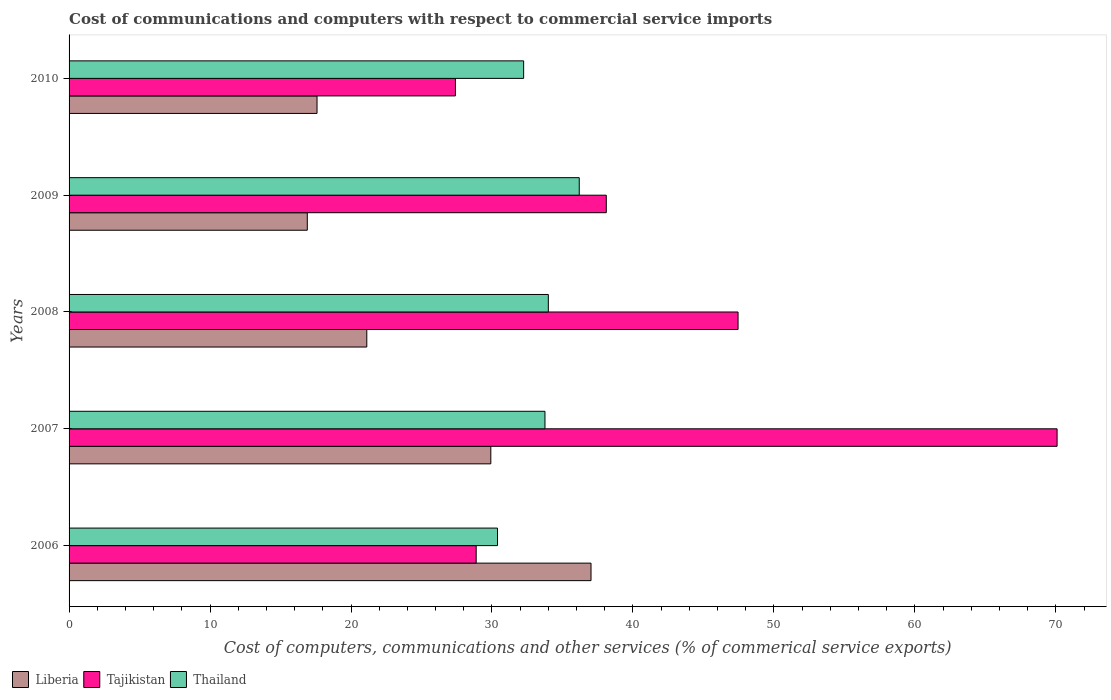Are the number of bars per tick equal to the number of legend labels?
Offer a very short reply. Yes. How many bars are there on the 1st tick from the top?
Your answer should be very brief. 3. How many bars are there on the 4th tick from the bottom?
Ensure brevity in your answer.  3. What is the label of the 5th group of bars from the top?
Your response must be concise. 2006. What is the cost of communications and computers in Thailand in 2010?
Your answer should be compact. 32.25. Across all years, what is the maximum cost of communications and computers in Tajikistan?
Provide a short and direct response. 70.09. Across all years, what is the minimum cost of communications and computers in Thailand?
Offer a very short reply. 30.39. In which year was the cost of communications and computers in Tajikistan minimum?
Ensure brevity in your answer.  2010. What is the total cost of communications and computers in Thailand in the graph?
Your answer should be very brief. 166.59. What is the difference between the cost of communications and computers in Tajikistan in 2007 and that in 2009?
Keep it short and to the point. 31.98. What is the difference between the cost of communications and computers in Thailand in 2010 and the cost of communications and computers in Liberia in 2006?
Make the answer very short. -4.78. What is the average cost of communications and computers in Tajikistan per year?
Offer a terse response. 42.39. In the year 2006, what is the difference between the cost of communications and computers in Tajikistan and cost of communications and computers in Thailand?
Your answer should be very brief. -1.51. What is the ratio of the cost of communications and computers in Thailand in 2008 to that in 2009?
Keep it short and to the point. 0.94. Is the difference between the cost of communications and computers in Tajikistan in 2007 and 2009 greater than the difference between the cost of communications and computers in Thailand in 2007 and 2009?
Keep it short and to the point. Yes. What is the difference between the highest and the second highest cost of communications and computers in Liberia?
Make the answer very short. 7.11. What is the difference between the highest and the lowest cost of communications and computers in Thailand?
Provide a succinct answer. 5.8. In how many years, is the cost of communications and computers in Liberia greater than the average cost of communications and computers in Liberia taken over all years?
Offer a terse response. 2. Is the sum of the cost of communications and computers in Thailand in 2006 and 2010 greater than the maximum cost of communications and computers in Liberia across all years?
Your answer should be compact. Yes. What does the 1st bar from the top in 2007 represents?
Offer a terse response. Thailand. What does the 1st bar from the bottom in 2007 represents?
Ensure brevity in your answer.  Liberia. Is it the case that in every year, the sum of the cost of communications and computers in Thailand and cost of communications and computers in Tajikistan is greater than the cost of communications and computers in Liberia?
Keep it short and to the point. Yes. Are all the bars in the graph horizontal?
Provide a succinct answer. Yes. How many years are there in the graph?
Your answer should be very brief. 5. Where does the legend appear in the graph?
Your answer should be compact. Bottom left. How many legend labels are there?
Provide a succinct answer. 3. How are the legend labels stacked?
Offer a very short reply. Horizontal. What is the title of the graph?
Give a very brief answer. Cost of communications and computers with respect to commercial service imports. Does "Suriname" appear as one of the legend labels in the graph?
Keep it short and to the point. No. What is the label or title of the X-axis?
Your answer should be compact. Cost of computers, communications and other services (% of commerical service exports). What is the label or title of the Y-axis?
Keep it short and to the point. Years. What is the Cost of computers, communications and other services (% of commerical service exports) of Liberia in 2006?
Offer a very short reply. 37.03. What is the Cost of computers, communications and other services (% of commerical service exports) of Tajikistan in 2006?
Your answer should be compact. 28.88. What is the Cost of computers, communications and other services (% of commerical service exports) in Thailand in 2006?
Your answer should be compact. 30.39. What is the Cost of computers, communications and other services (% of commerical service exports) in Liberia in 2007?
Give a very brief answer. 29.92. What is the Cost of computers, communications and other services (% of commerical service exports) in Tajikistan in 2007?
Your response must be concise. 70.09. What is the Cost of computers, communications and other services (% of commerical service exports) in Thailand in 2007?
Your response must be concise. 33.76. What is the Cost of computers, communications and other services (% of commerical service exports) in Liberia in 2008?
Give a very brief answer. 21.12. What is the Cost of computers, communications and other services (% of commerical service exports) in Tajikistan in 2008?
Give a very brief answer. 47.46. What is the Cost of computers, communications and other services (% of commerical service exports) of Thailand in 2008?
Make the answer very short. 34. What is the Cost of computers, communications and other services (% of commerical service exports) of Liberia in 2009?
Provide a short and direct response. 16.9. What is the Cost of computers, communications and other services (% of commerical service exports) in Tajikistan in 2009?
Keep it short and to the point. 38.11. What is the Cost of computers, communications and other services (% of commerical service exports) of Thailand in 2009?
Offer a terse response. 36.19. What is the Cost of computers, communications and other services (% of commerical service exports) in Liberia in 2010?
Offer a terse response. 17.59. What is the Cost of computers, communications and other services (% of commerical service exports) of Tajikistan in 2010?
Give a very brief answer. 27.41. What is the Cost of computers, communications and other services (% of commerical service exports) in Thailand in 2010?
Give a very brief answer. 32.25. Across all years, what is the maximum Cost of computers, communications and other services (% of commerical service exports) of Liberia?
Offer a very short reply. 37.03. Across all years, what is the maximum Cost of computers, communications and other services (% of commerical service exports) of Tajikistan?
Keep it short and to the point. 70.09. Across all years, what is the maximum Cost of computers, communications and other services (% of commerical service exports) of Thailand?
Offer a terse response. 36.19. Across all years, what is the minimum Cost of computers, communications and other services (% of commerical service exports) of Liberia?
Give a very brief answer. 16.9. Across all years, what is the minimum Cost of computers, communications and other services (% of commerical service exports) in Tajikistan?
Keep it short and to the point. 27.41. Across all years, what is the minimum Cost of computers, communications and other services (% of commerical service exports) in Thailand?
Your answer should be very brief. 30.39. What is the total Cost of computers, communications and other services (% of commerical service exports) of Liberia in the graph?
Give a very brief answer. 122.55. What is the total Cost of computers, communications and other services (% of commerical service exports) of Tajikistan in the graph?
Keep it short and to the point. 211.94. What is the total Cost of computers, communications and other services (% of commerical service exports) of Thailand in the graph?
Provide a short and direct response. 166.59. What is the difference between the Cost of computers, communications and other services (% of commerical service exports) of Liberia in 2006 and that in 2007?
Ensure brevity in your answer.  7.11. What is the difference between the Cost of computers, communications and other services (% of commerical service exports) of Tajikistan in 2006 and that in 2007?
Offer a very short reply. -41.21. What is the difference between the Cost of computers, communications and other services (% of commerical service exports) of Thailand in 2006 and that in 2007?
Provide a short and direct response. -3.37. What is the difference between the Cost of computers, communications and other services (% of commerical service exports) of Liberia in 2006 and that in 2008?
Your answer should be very brief. 15.91. What is the difference between the Cost of computers, communications and other services (% of commerical service exports) in Tajikistan in 2006 and that in 2008?
Offer a terse response. -18.58. What is the difference between the Cost of computers, communications and other services (% of commerical service exports) in Thailand in 2006 and that in 2008?
Your response must be concise. -3.6. What is the difference between the Cost of computers, communications and other services (% of commerical service exports) of Liberia in 2006 and that in 2009?
Ensure brevity in your answer.  20.13. What is the difference between the Cost of computers, communications and other services (% of commerical service exports) of Tajikistan in 2006 and that in 2009?
Your response must be concise. -9.23. What is the difference between the Cost of computers, communications and other services (% of commerical service exports) in Thailand in 2006 and that in 2009?
Offer a very short reply. -5.8. What is the difference between the Cost of computers, communications and other services (% of commerical service exports) of Liberia in 2006 and that in 2010?
Keep it short and to the point. 19.44. What is the difference between the Cost of computers, communications and other services (% of commerical service exports) in Tajikistan in 2006 and that in 2010?
Give a very brief answer. 1.47. What is the difference between the Cost of computers, communications and other services (% of commerical service exports) in Thailand in 2006 and that in 2010?
Your response must be concise. -1.85. What is the difference between the Cost of computers, communications and other services (% of commerical service exports) in Liberia in 2007 and that in 2008?
Offer a very short reply. 8.8. What is the difference between the Cost of computers, communications and other services (% of commerical service exports) of Tajikistan in 2007 and that in 2008?
Provide a succinct answer. 22.63. What is the difference between the Cost of computers, communications and other services (% of commerical service exports) of Thailand in 2007 and that in 2008?
Provide a short and direct response. -0.24. What is the difference between the Cost of computers, communications and other services (% of commerical service exports) of Liberia in 2007 and that in 2009?
Offer a very short reply. 13.02. What is the difference between the Cost of computers, communications and other services (% of commerical service exports) of Tajikistan in 2007 and that in 2009?
Offer a terse response. 31.98. What is the difference between the Cost of computers, communications and other services (% of commerical service exports) of Thailand in 2007 and that in 2009?
Offer a terse response. -2.43. What is the difference between the Cost of computers, communications and other services (% of commerical service exports) of Liberia in 2007 and that in 2010?
Give a very brief answer. 12.33. What is the difference between the Cost of computers, communications and other services (% of commerical service exports) of Tajikistan in 2007 and that in 2010?
Your response must be concise. 42.68. What is the difference between the Cost of computers, communications and other services (% of commerical service exports) of Thailand in 2007 and that in 2010?
Provide a short and direct response. 1.51. What is the difference between the Cost of computers, communications and other services (% of commerical service exports) in Liberia in 2008 and that in 2009?
Offer a very short reply. 4.22. What is the difference between the Cost of computers, communications and other services (% of commerical service exports) of Tajikistan in 2008 and that in 2009?
Provide a succinct answer. 9.35. What is the difference between the Cost of computers, communications and other services (% of commerical service exports) of Thailand in 2008 and that in 2009?
Offer a very short reply. -2.19. What is the difference between the Cost of computers, communications and other services (% of commerical service exports) in Liberia in 2008 and that in 2010?
Give a very brief answer. 3.53. What is the difference between the Cost of computers, communications and other services (% of commerical service exports) of Tajikistan in 2008 and that in 2010?
Your answer should be very brief. 20.05. What is the difference between the Cost of computers, communications and other services (% of commerical service exports) in Thailand in 2008 and that in 2010?
Your answer should be compact. 1.75. What is the difference between the Cost of computers, communications and other services (% of commerical service exports) of Liberia in 2009 and that in 2010?
Give a very brief answer. -0.69. What is the difference between the Cost of computers, communications and other services (% of commerical service exports) of Tajikistan in 2009 and that in 2010?
Give a very brief answer. 10.7. What is the difference between the Cost of computers, communications and other services (% of commerical service exports) in Thailand in 2009 and that in 2010?
Offer a very short reply. 3.94. What is the difference between the Cost of computers, communications and other services (% of commerical service exports) in Liberia in 2006 and the Cost of computers, communications and other services (% of commerical service exports) in Tajikistan in 2007?
Provide a succinct answer. -33.06. What is the difference between the Cost of computers, communications and other services (% of commerical service exports) of Liberia in 2006 and the Cost of computers, communications and other services (% of commerical service exports) of Thailand in 2007?
Provide a short and direct response. 3.27. What is the difference between the Cost of computers, communications and other services (% of commerical service exports) of Tajikistan in 2006 and the Cost of computers, communications and other services (% of commerical service exports) of Thailand in 2007?
Your answer should be very brief. -4.88. What is the difference between the Cost of computers, communications and other services (% of commerical service exports) of Liberia in 2006 and the Cost of computers, communications and other services (% of commerical service exports) of Tajikistan in 2008?
Your answer should be very brief. -10.43. What is the difference between the Cost of computers, communications and other services (% of commerical service exports) in Liberia in 2006 and the Cost of computers, communications and other services (% of commerical service exports) in Thailand in 2008?
Your answer should be compact. 3.03. What is the difference between the Cost of computers, communications and other services (% of commerical service exports) in Tajikistan in 2006 and the Cost of computers, communications and other services (% of commerical service exports) in Thailand in 2008?
Your answer should be very brief. -5.12. What is the difference between the Cost of computers, communications and other services (% of commerical service exports) in Liberia in 2006 and the Cost of computers, communications and other services (% of commerical service exports) in Tajikistan in 2009?
Your response must be concise. -1.08. What is the difference between the Cost of computers, communications and other services (% of commerical service exports) of Liberia in 2006 and the Cost of computers, communications and other services (% of commerical service exports) of Thailand in 2009?
Your answer should be compact. 0.83. What is the difference between the Cost of computers, communications and other services (% of commerical service exports) in Tajikistan in 2006 and the Cost of computers, communications and other services (% of commerical service exports) in Thailand in 2009?
Provide a succinct answer. -7.31. What is the difference between the Cost of computers, communications and other services (% of commerical service exports) of Liberia in 2006 and the Cost of computers, communications and other services (% of commerical service exports) of Tajikistan in 2010?
Offer a terse response. 9.62. What is the difference between the Cost of computers, communications and other services (% of commerical service exports) in Liberia in 2006 and the Cost of computers, communications and other services (% of commerical service exports) in Thailand in 2010?
Ensure brevity in your answer.  4.78. What is the difference between the Cost of computers, communications and other services (% of commerical service exports) of Tajikistan in 2006 and the Cost of computers, communications and other services (% of commerical service exports) of Thailand in 2010?
Make the answer very short. -3.37. What is the difference between the Cost of computers, communications and other services (% of commerical service exports) in Liberia in 2007 and the Cost of computers, communications and other services (% of commerical service exports) in Tajikistan in 2008?
Your response must be concise. -17.54. What is the difference between the Cost of computers, communications and other services (% of commerical service exports) of Liberia in 2007 and the Cost of computers, communications and other services (% of commerical service exports) of Thailand in 2008?
Ensure brevity in your answer.  -4.08. What is the difference between the Cost of computers, communications and other services (% of commerical service exports) of Tajikistan in 2007 and the Cost of computers, communications and other services (% of commerical service exports) of Thailand in 2008?
Offer a terse response. 36.09. What is the difference between the Cost of computers, communications and other services (% of commerical service exports) of Liberia in 2007 and the Cost of computers, communications and other services (% of commerical service exports) of Tajikistan in 2009?
Offer a very short reply. -8.19. What is the difference between the Cost of computers, communications and other services (% of commerical service exports) of Liberia in 2007 and the Cost of computers, communications and other services (% of commerical service exports) of Thailand in 2009?
Keep it short and to the point. -6.27. What is the difference between the Cost of computers, communications and other services (% of commerical service exports) of Tajikistan in 2007 and the Cost of computers, communications and other services (% of commerical service exports) of Thailand in 2009?
Ensure brevity in your answer.  33.9. What is the difference between the Cost of computers, communications and other services (% of commerical service exports) in Liberia in 2007 and the Cost of computers, communications and other services (% of commerical service exports) in Tajikistan in 2010?
Give a very brief answer. 2.51. What is the difference between the Cost of computers, communications and other services (% of commerical service exports) of Liberia in 2007 and the Cost of computers, communications and other services (% of commerical service exports) of Thailand in 2010?
Your response must be concise. -2.33. What is the difference between the Cost of computers, communications and other services (% of commerical service exports) of Tajikistan in 2007 and the Cost of computers, communications and other services (% of commerical service exports) of Thailand in 2010?
Offer a very short reply. 37.84. What is the difference between the Cost of computers, communications and other services (% of commerical service exports) of Liberia in 2008 and the Cost of computers, communications and other services (% of commerical service exports) of Tajikistan in 2009?
Offer a very short reply. -16.99. What is the difference between the Cost of computers, communications and other services (% of commerical service exports) in Liberia in 2008 and the Cost of computers, communications and other services (% of commerical service exports) in Thailand in 2009?
Offer a very short reply. -15.07. What is the difference between the Cost of computers, communications and other services (% of commerical service exports) of Tajikistan in 2008 and the Cost of computers, communications and other services (% of commerical service exports) of Thailand in 2009?
Give a very brief answer. 11.27. What is the difference between the Cost of computers, communications and other services (% of commerical service exports) of Liberia in 2008 and the Cost of computers, communications and other services (% of commerical service exports) of Tajikistan in 2010?
Your answer should be very brief. -6.29. What is the difference between the Cost of computers, communications and other services (% of commerical service exports) of Liberia in 2008 and the Cost of computers, communications and other services (% of commerical service exports) of Thailand in 2010?
Your response must be concise. -11.13. What is the difference between the Cost of computers, communications and other services (% of commerical service exports) of Tajikistan in 2008 and the Cost of computers, communications and other services (% of commerical service exports) of Thailand in 2010?
Your response must be concise. 15.21. What is the difference between the Cost of computers, communications and other services (% of commerical service exports) of Liberia in 2009 and the Cost of computers, communications and other services (% of commerical service exports) of Tajikistan in 2010?
Provide a succinct answer. -10.51. What is the difference between the Cost of computers, communications and other services (% of commerical service exports) in Liberia in 2009 and the Cost of computers, communications and other services (% of commerical service exports) in Thailand in 2010?
Ensure brevity in your answer.  -15.35. What is the difference between the Cost of computers, communications and other services (% of commerical service exports) in Tajikistan in 2009 and the Cost of computers, communications and other services (% of commerical service exports) in Thailand in 2010?
Ensure brevity in your answer.  5.86. What is the average Cost of computers, communications and other services (% of commerical service exports) of Liberia per year?
Make the answer very short. 24.51. What is the average Cost of computers, communications and other services (% of commerical service exports) of Tajikistan per year?
Provide a succinct answer. 42.39. What is the average Cost of computers, communications and other services (% of commerical service exports) in Thailand per year?
Keep it short and to the point. 33.32. In the year 2006, what is the difference between the Cost of computers, communications and other services (% of commerical service exports) in Liberia and Cost of computers, communications and other services (% of commerical service exports) in Tajikistan?
Your answer should be very brief. 8.15. In the year 2006, what is the difference between the Cost of computers, communications and other services (% of commerical service exports) in Liberia and Cost of computers, communications and other services (% of commerical service exports) in Thailand?
Keep it short and to the point. 6.63. In the year 2006, what is the difference between the Cost of computers, communications and other services (% of commerical service exports) of Tajikistan and Cost of computers, communications and other services (% of commerical service exports) of Thailand?
Keep it short and to the point. -1.51. In the year 2007, what is the difference between the Cost of computers, communications and other services (% of commerical service exports) of Liberia and Cost of computers, communications and other services (% of commerical service exports) of Tajikistan?
Your answer should be very brief. -40.17. In the year 2007, what is the difference between the Cost of computers, communications and other services (% of commerical service exports) of Liberia and Cost of computers, communications and other services (% of commerical service exports) of Thailand?
Your answer should be very brief. -3.84. In the year 2007, what is the difference between the Cost of computers, communications and other services (% of commerical service exports) of Tajikistan and Cost of computers, communications and other services (% of commerical service exports) of Thailand?
Ensure brevity in your answer.  36.33. In the year 2008, what is the difference between the Cost of computers, communications and other services (% of commerical service exports) in Liberia and Cost of computers, communications and other services (% of commerical service exports) in Tajikistan?
Give a very brief answer. -26.34. In the year 2008, what is the difference between the Cost of computers, communications and other services (% of commerical service exports) in Liberia and Cost of computers, communications and other services (% of commerical service exports) in Thailand?
Offer a terse response. -12.88. In the year 2008, what is the difference between the Cost of computers, communications and other services (% of commerical service exports) of Tajikistan and Cost of computers, communications and other services (% of commerical service exports) of Thailand?
Give a very brief answer. 13.46. In the year 2009, what is the difference between the Cost of computers, communications and other services (% of commerical service exports) in Liberia and Cost of computers, communications and other services (% of commerical service exports) in Tajikistan?
Keep it short and to the point. -21.21. In the year 2009, what is the difference between the Cost of computers, communications and other services (% of commerical service exports) of Liberia and Cost of computers, communications and other services (% of commerical service exports) of Thailand?
Your answer should be compact. -19.29. In the year 2009, what is the difference between the Cost of computers, communications and other services (% of commerical service exports) in Tajikistan and Cost of computers, communications and other services (% of commerical service exports) in Thailand?
Your response must be concise. 1.92. In the year 2010, what is the difference between the Cost of computers, communications and other services (% of commerical service exports) of Liberia and Cost of computers, communications and other services (% of commerical service exports) of Tajikistan?
Ensure brevity in your answer.  -9.82. In the year 2010, what is the difference between the Cost of computers, communications and other services (% of commerical service exports) in Liberia and Cost of computers, communications and other services (% of commerical service exports) in Thailand?
Provide a short and direct response. -14.66. In the year 2010, what is the difference between the Cost of computers, communications and other services (% of commerical service exports) in Tajikistan and Cost of computers, communications and other services (% of commerical service exports) in Thailand?
Your answer should be very brief. -4.84. What is the ratio of the Cost of computers, communications and other services (% of commerical service exports) of Liberia in 2006 to that in 2007?
Provide a succinct answer. 1.24. What is the ratio of the Cost of computers, communications and other services (% of commerical service exports) of Tajikistan in 2006 to that in 2007?
Offer a very short reply. 0.41. What is the ratio of the Cost of computers, communications and other services (% of commerical service exports) in Thailand in 2006 to that in 2007?
Your answer should be compact. 0.9. What is the ratio of the Cost of computers, communications and other services (% of commerical service exports) of Liberia in 2006 to that in 2008?
Provide a succinct answer. 1.75. What is the ratio of the Cost of computers, communications and other services (% of commerical service exports) of Tajikistan in 2006 to that in 2008?
Offer a terse response. 0.61. What is the ratio of the Cost of computers, communications and other services (% of commerical service exports) in Thailand in 2006 to that in 2008?
Make the answer very short. 0.89. What is the ratio of the Cost of computers, communications and other services (% of commerical service exports) of Liberia in 2006 to that in 2009?
Offer a very short reply. 2.19. What is the ratio of the Cost of computers, communications and other services (% of commerical service exports) of Tajikistan in 2006 to that in 2009?
Make the answer very short. 0.76. What is the ratio of the Cost of computers, communications and other services (% of commerical service exports) of Thailand in 2006 to that in 2009?
Your answer should be compact. 0.84. What is the ratio of the Cost of computers, communications and other services (% of commerical service exports) of Liberia in 2006 to that in 2010?
Your answer should be very brief. 2.1. What is the ratio of the Cost of computers, communications and other services (% of commerical service exports) of Tajikistan in 2006 to that in 2010?
Your answer should be very brief. 1.05. What is the ratio of the Cost of computers, communications and other services (% of commerical service exports) in Thailand in 2006 to that in 2010?
Make the answer very short. 0.94. What is the ratio of the Cost of computers, communications and other services (% of commerical service exports) in Liberia in 2007 to that in 2008?
Provide a short and direct response. 1.42. What is the ratio of the Cost of computers, communications and other services (% of commerical service exports) of Tajikistan in 2007 to that in 2008?
Make the answer very short. 1.48. What is the ratio of the Cost of computers, communications and other services (% of commerical service exports) of Liberia in 2007 to that in 2009?
Provide a short and direct response. 1.77. What is the ratio of the Cost of computers, communications and other services (% of commerical service exports) in Tajikistan in 2007 to that in 2009?
Provide a succinct answer. 1.84. What is the ratio of the Cost of computers, communications and other services (% of commerical service exports) in Thailand in 2007 to that in 2009?
Your answer should be compact. 0.93. What is the ratio of the Cost of computers, communications and other services (% of commerical service exports) in Liberia in 2007 to that in 2010?
Your answer should be very brief. 1.7. What is the ratio of the Cost of computers, communications and other services (% of commerical service exports) in Tajikistan in 2007 to that in 2010?
Provide a succinct answer. 2.56. What is the ratio of the Cost of computers, communications and other services (% of commerical service exports) in Thailand in 2007 to that in 2010?
Your response must be concise. 1.05. What is the ratio of the Cost of computers, communications and other services (% of commerical service exports) of Liberia in 2008 to that in 2009?
Offer a very short reply. 1.25. What is the ratio of the Cost of computers, communications and other services (% of commerical service exports) of Tajikistan in 2008 to that in 2009?
Provide a short and direct response. 1.25. What is the ratio of the Cost of computers, communications and other services (% of commerical service exports) of Thailand in 2008 to that in 2009?
Provide a short and direct response. 0.94. What is the ratio of the Cost of computers, communications and other services (% of commerical service exports) of Liberia in 2008 to that in 2010?
Keep it short and to the point. 1.2. What is the ratio of the Cost of computers, communications and other services (% of commerical service exports) of Tajikistan in 2008 to that in 2010?
Your response must be concise. 1.73. What is the ratio of the Cost of computers, communications and other services (% of commerical service exports) in Thailand in 2008 to that in 2010?
Keep it short and to the point. 1.05. What is the ratio of the Cost of computers, communications and other services (% of commerical service exports) of Liberia in 2009 to that in 2010?
Offer a terse response. 0.96. What is the ratio of the Cost of computers, communications and other services (% of commerical service exports) in Tajikistan in 2009 to that in 2010?
Offer a very short reply. 1.39. What is the ratio of the Cost of computers, communications and other services (% of commerical service exports) of Thailand in 2009 to that in 2010?
Ensure brevity in your answer.  1.12. What is the difference between the highest and the second highest Cost of computers, communications and other services (% of commerical service exports) of Liberia?
Your answer should be very brief. 7.11. What is the difference between the highest and the second highest Cost of computers, communications and other services (% of commerical service exports) of Tajikistan?
Your response must be concise. 22.63. What is the difference between the highest and the second highest Cost of computers, communications and other services (% of commerical service exports) in Thailand?
Keep it short and to the point. 2.19. What is the difference between the highest and the lowest Cost of computers, communications and other services (% of commerical service exports) of Liberia?
Your answer should be very brief. 20.13. What is the difference between the highest and the lowest Cost of computers, communications and other services (% of commerical service exports) in Tajikistan?
Your response must be concise. 42.68. What is the difference between the highest and the lowest Cost of computers, communications and other services (% of commerical service exports) of Thailand?
Give a very brief answer. 5.8. 